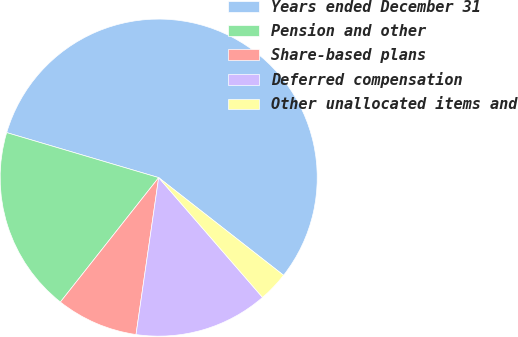Convert chart to OTSL. <chart><loc_0><loc_0><loc_500><loc_500><pie_chart><fcel>Years ended December 31<fcel>Pension and other<fcel>Share-based plans<fcel>Deferred compensation<fcel>Other unallocated items and<nl><fcel>55.98%<fcel>18.94%<fcel>8.36%<fcel>13.65%<fcel>3.07%<nl></chart> 